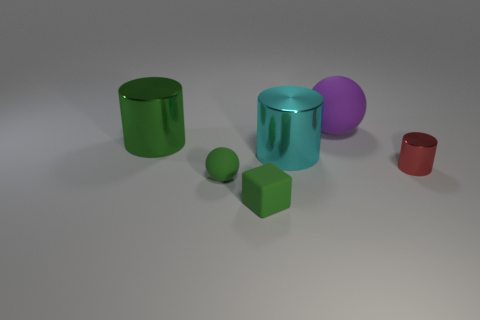Add 3 brown cylinders. How many objects exist? 9 Subtract all balls. How many objects are left? 4 Add 4 red metal objects. How many red metal objects exist? 5 Subtract 0 brown balls. How many objects are left? 6 Subtract all metallic things. Subtract all small blocks. How many objects are left? 2 Add 3 cyan things. How many cyan things are left? 4 